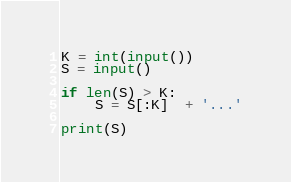Convert code to text. <code><loc_0><loc_0><loc_500><loc_500><_Python_>K = int(input()) 
S = input()

if len(S) > K:
    S = S[:K]  + '...'

print(S)</code> 